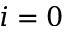Convert formula to latex. <formula><loc_0><loc_0><loc_500><loc_500>i = 0</formula> 